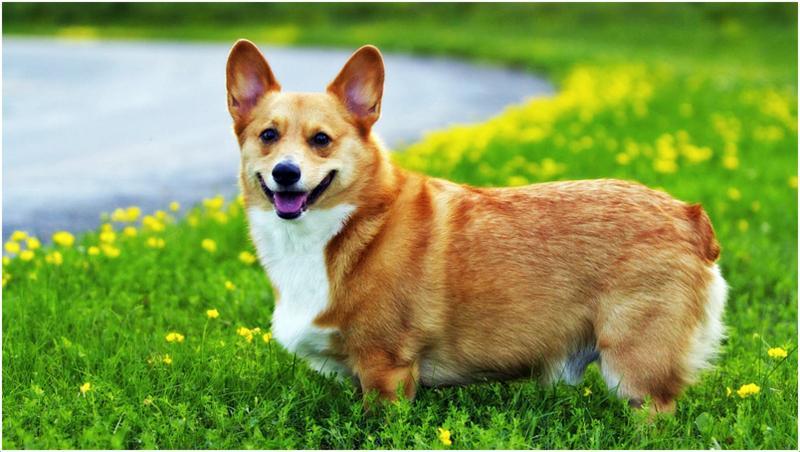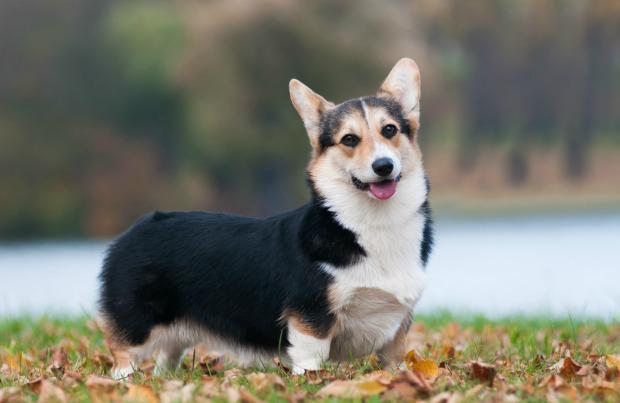The first image is the image on the left, the second image is the image on the right. Assess this claim about the two images: "Two corgies have their ears pointed upward and their mouths open and smiling with tongues showing.". Correct or not? Answer yes or no. Yes. The first image is the image on the left, the second image is the image on the right. Analyze the images presented: Is the assertion "An image shows a corgi dog bounding across the grass, with at least one front paw raised." valid? Answer yes or no. No. 